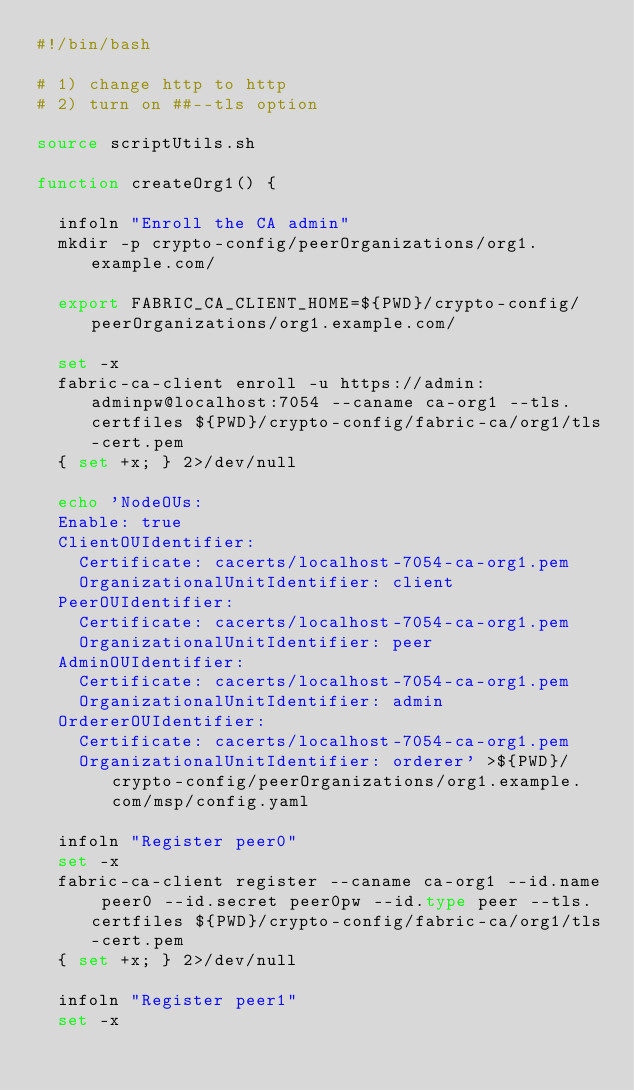<code> <loc_0><loc_0><loc_500><loc_500><_Bash_>#!/bin/bash

# 1) change http to http
# 2) turn on ##--tls option

source scriptUtils.sh

function createOrg1() {

  infoln "Enroll the CA admin"
  mkdir -p crypto-config/peerOrganizations/org1.example.com/

  export FABRIC_CA_CLIENT_HOME=${PWD}/crypto-config/peerOrganizations/org1.example.com/

  set -x
  fabric-ca-client enroll -u https://admin:adminpw@localhost:7054 --caname ca-org1 --tls.certfiles ${PWD}/crypto-config/fabric-ca/org1/tls-cert.pem
  { set +x; } 2>/dev/null

  echo 'NodeOUs:
  Enable: true
  ClientOUIdentifier:
    Certificate: cacerts/localhost-7054-ca-org1.pem
    OrganizationalUnitIdentifier: client
  PeerOUIdentifier:
    Certificate: cacerts/localhost-7054-ca-org1.pem
    OrganizationalUnitIdentifier: peer
  AdminOUIdentifier:
    Certificate: cacerts/localhost-7054-ca-org1.pem
    OrganizationalUnitIdentifier: admin
  OrdererOUIdentifier:
    Certificate: cacerts/localhost-7054-ca-org1.pem
    OrganizationalUnitIdentifier: orderer' >${PWD}/crypto-config/peerOrganizations/org1.example.com/msp/config.yaml

  infoln "Register peer0"
  set -x
  fabric-ca-client register --caname ca-org1 --id.name peer0 --id.secret peer0pw --id.type peer --tls.certfiles ${PWD}/crypto-config/fabric-ca/org1/tls-cert.pem
  { set +x; } 2>/dev/null

  infoln "Register peer1"
  set -x</code> 